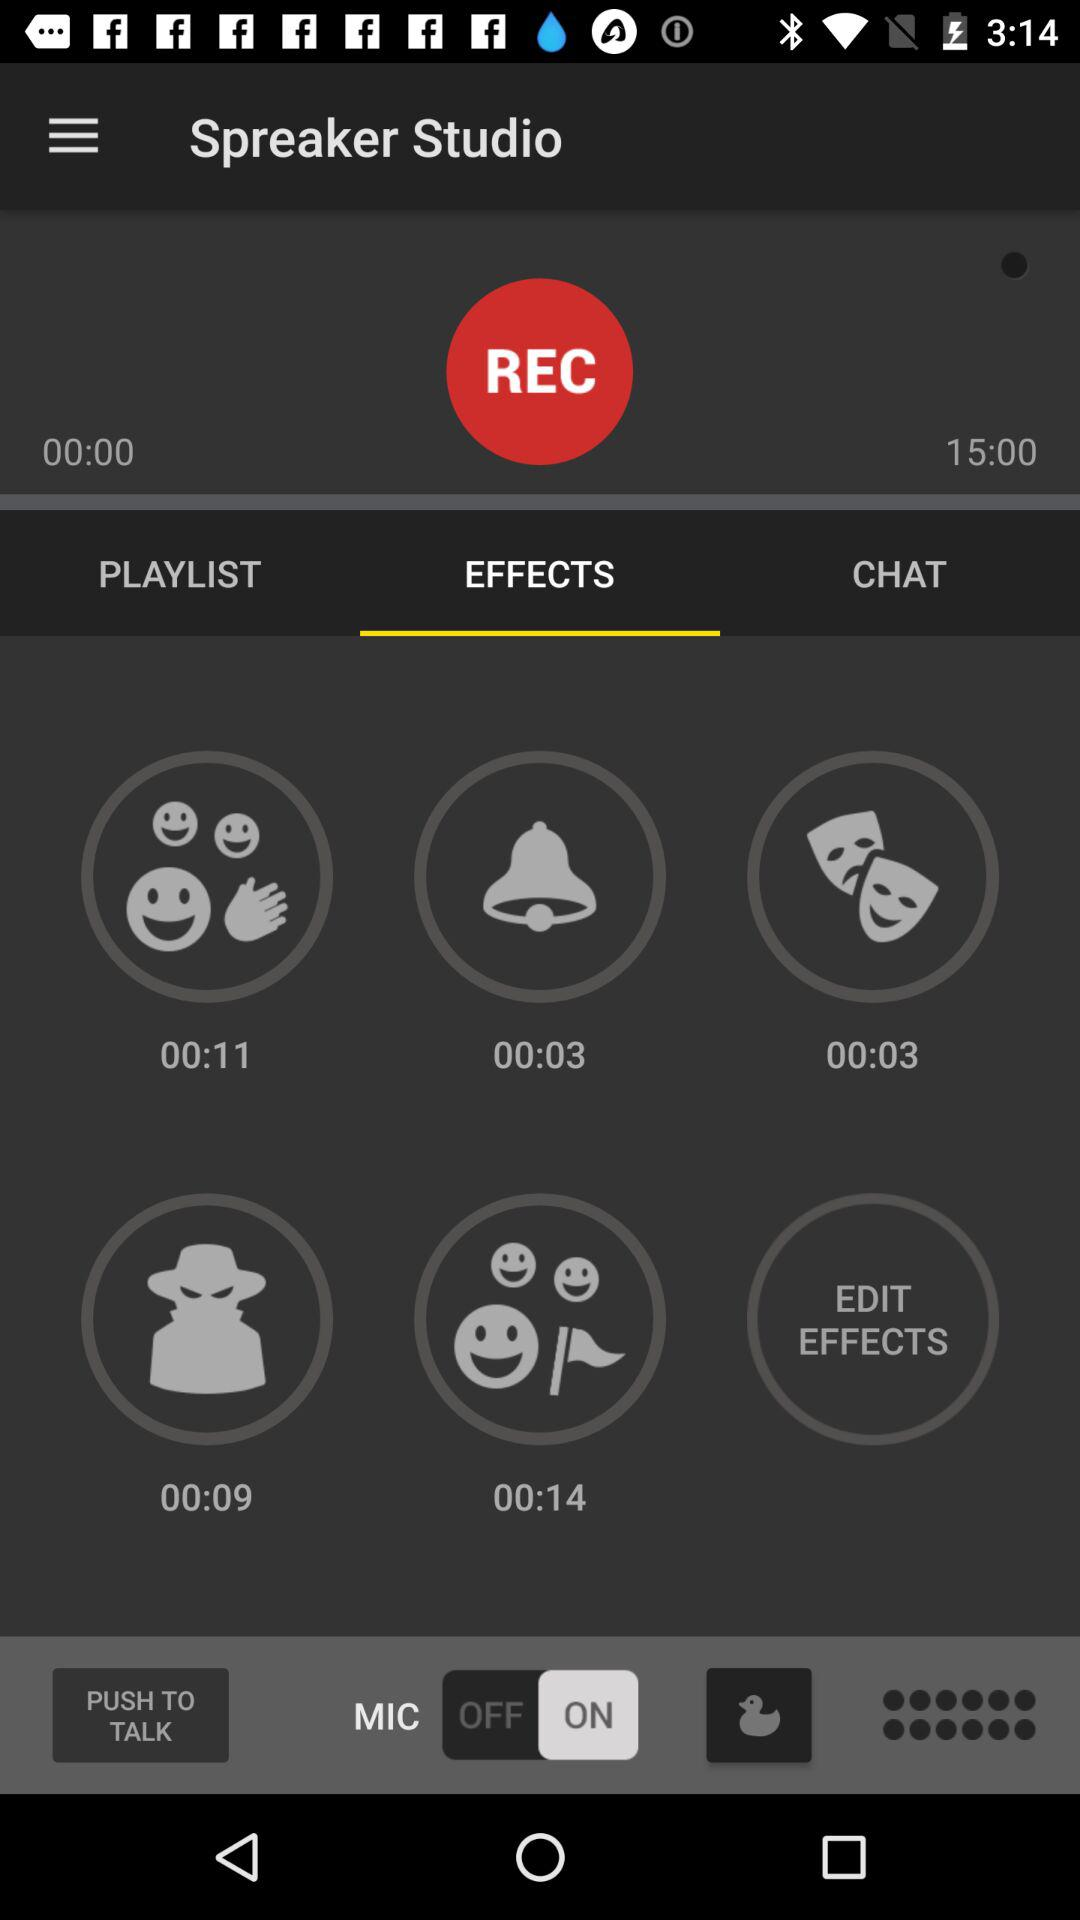Which category of "Spreaker Studio" am I on? You are on "EFFECTS" category. 